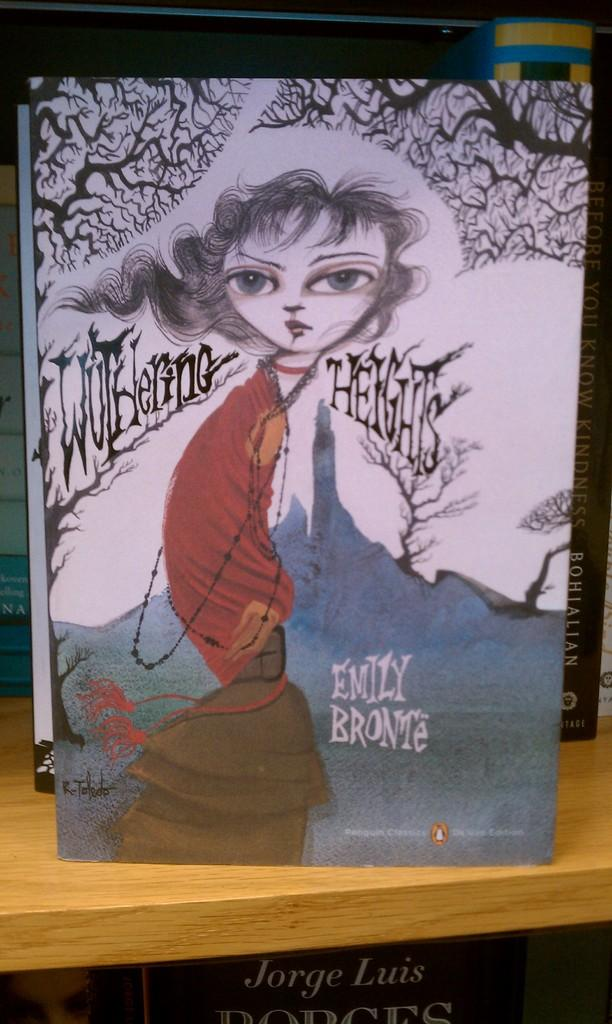Provide a one-sentence caption for the provided image. a painting of a girl by emily bronte. 